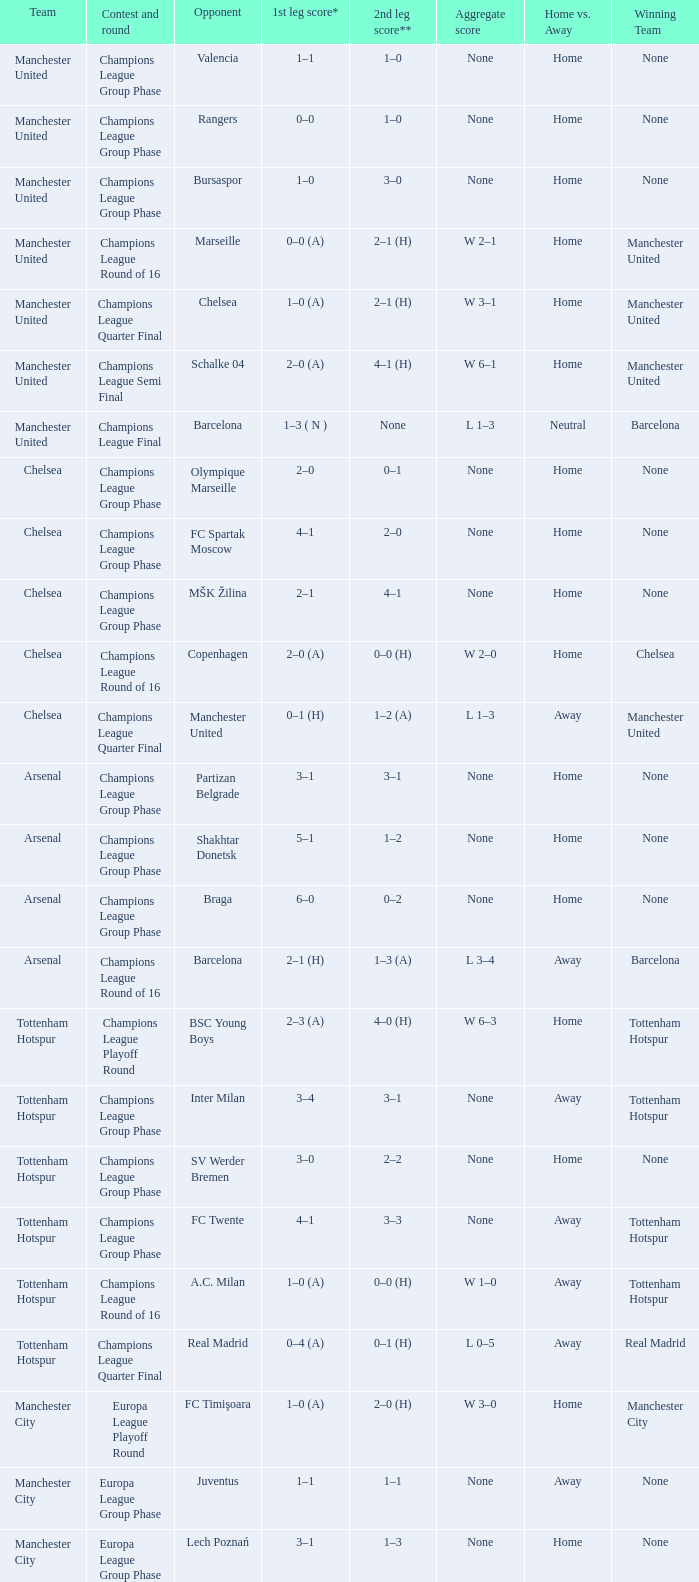What was the score between Marseille and Manchester United on the second leg of the Champions League Round of 16? 2–1 (H). 